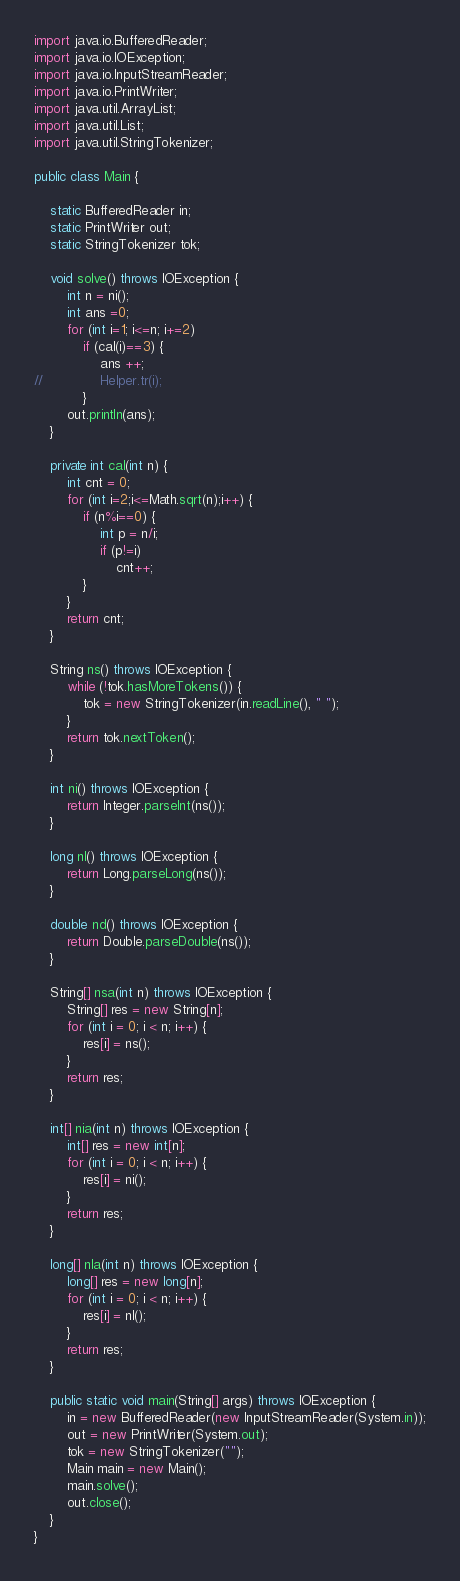<code> <loc_0><loc_0><loc_500><loc_500><_Java_>import java.io.BufferedReader;
import java.io.IOException;
import java.io.InputStreamReader;
import java.io.PrintWriter;
import java.util.ArrayList;
import java.util.List;
import java.util.StringTokenizer;

public class Main {

	static BufferedReader in;
	static PrintWriter out;
	static StringTokenizer tok;

	void solve() throws IOException {
		int n = ni();
		int ans =0;
		for (int i=1; i<=n; i+=2)
			if (cal(i)==3) {
				ans ++;
//				Helper.tr(i);
			}
		out.println(ans);
	}

	private int cal(int n) {
		int cnt = 0;
		for (int i=2;i<=Math.sqrt(n);i++) {
			if (n%i==0) {
				int p = n/i;
				if (p!=i)
					cnt++;
			}
		}
		return cnt;
	}

	String ns() throws IOException {
		while (!tok.hasMoreTokens()) {
			tok = new StringTokenizer(in.readLine(), " ");
		}
		return tok.nextToken();
	}

	int ni() throws IOException {
		return Integer.parseInt(ns());
	}

	long nl() throws IOException {
		return Long.parseLong(ns());
	}

	double nd() throws IOException {
		return Double.parseDouble(ns());
	}

	String[] nsa(int n) throws IOException {
		String[] res = new String[n];
		for (int i = 0; i < n; i++) {
			res[i] = ns();
		}
		return res;
	}

	int[] nia(int n) throws IOException {
		int[] res = new int[n];
		for (int i = 0; i < n; i++) {
			res[i] = ni();
		}
		return res;
	}

	long[] nla(int n) throws IOException {
		long[] res = new long[n];
		for (int i = 0; i < n; i++) {
			res[i] = nl();
		}
		return res;
	}

	public static void main(String[] args) throws IOException {
		in = new BufferedReader(new InputStreamReader(System.in));
		out = new PrintWriter(System.out);
		tok = new StringTokenizer("");
		Main main = new Main();
		main.solve();
		out.close();
	}
}</code> 